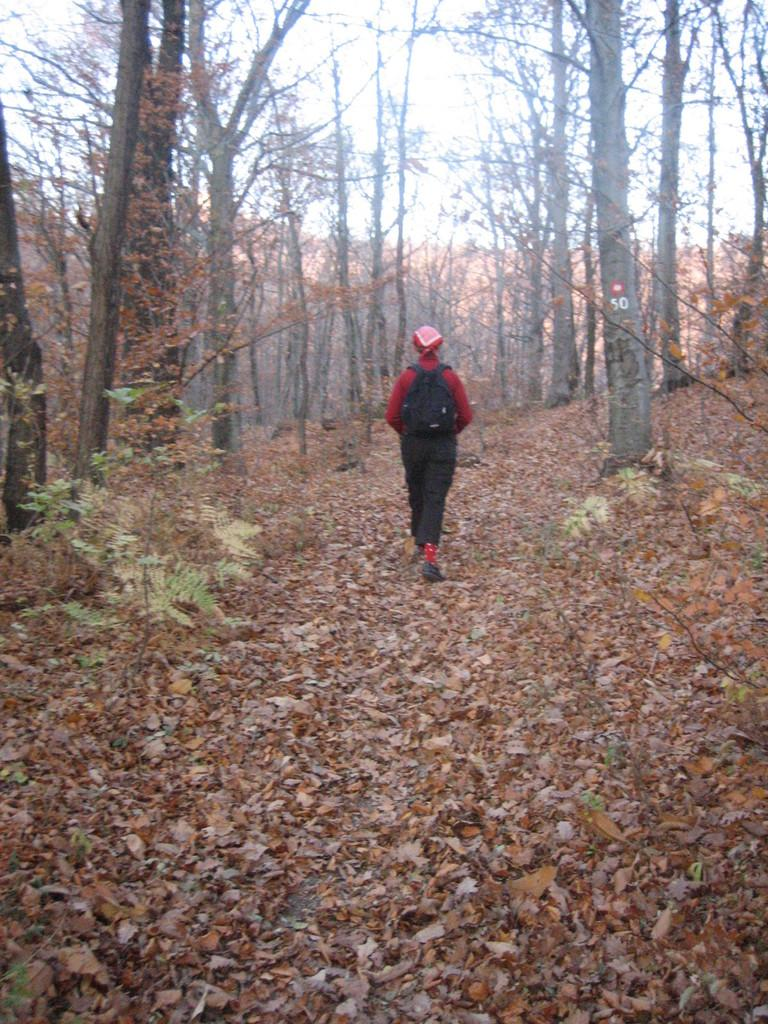What is the person in the image doing? There is a person walking in the image. What covers the land in the image? The land in the image is covered with leaves. What can be seen in the background of the image? There are trees in the background of the image. What type of advertisement can be seen on the cow in the image? There is no cow present in the image, and therefore no advertisement can be seen on it. 